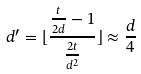Convert formula to latex. <formula><loc_0><loc_0><loc_500><loc_500>d ^ { \prime } = \lfloor \frac { \frac { t } { 2 d } - 1 } { \frac { 2 t } { d ^ { 2 } } } \rfloor \approx \frac { d } { 4 }</formula> 